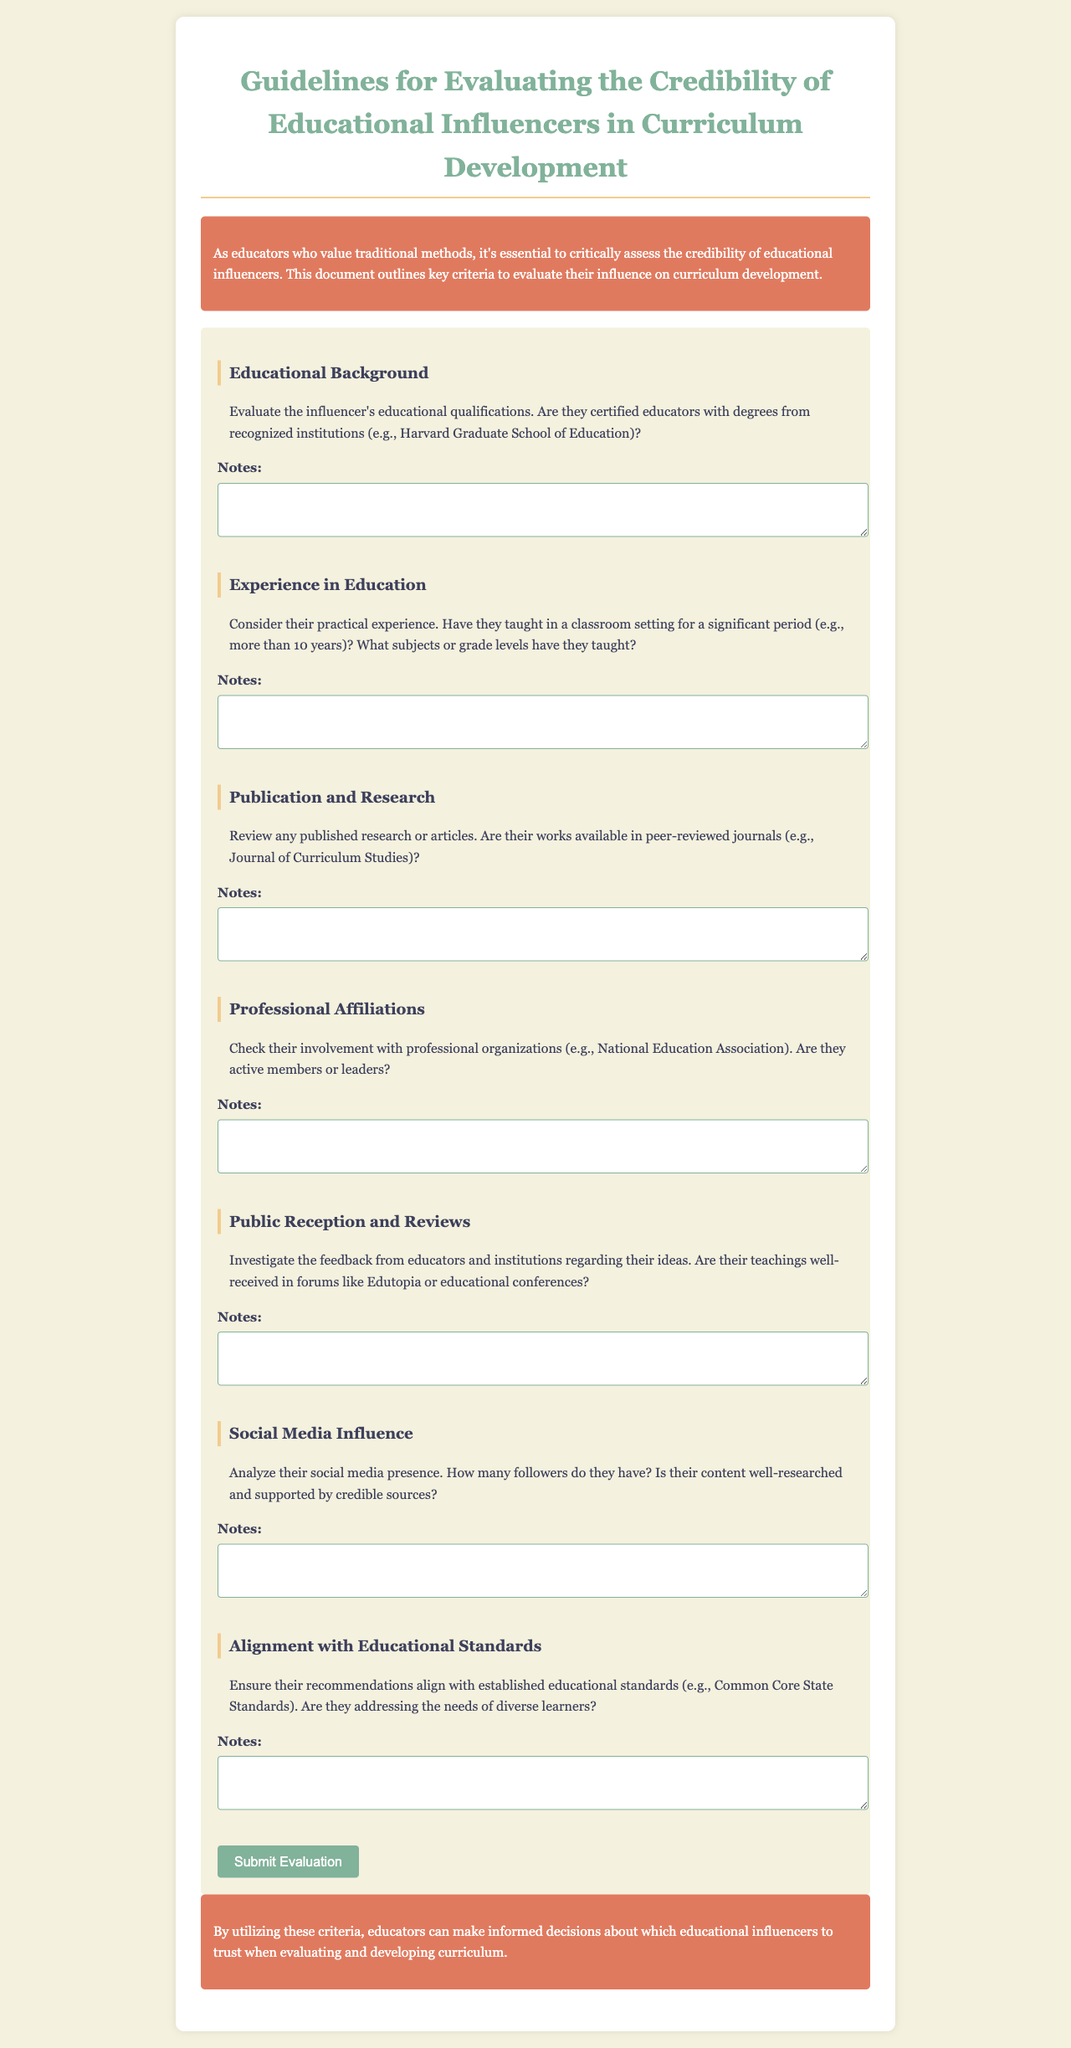What is the title of the document? The title of the document is clearly stated in the header, which is "Guidelines for Evaluating the Credibility of Educational Influencers in Curriculum Development."
Answer: Guidelines for Evaluating the Credibility of Educational Influencers in Curriculum Development How many criteria are listed for evaluating educational influencers? The number of criteria can be counted in the document, which are seven in total.
Answer: Seven What is one suggested requirement for the influencer's educational background? The document specifies that influencers should ideally be certified educators with degrees from recognized institutions such as Harvard Graduate School of Education.
Answer: Certified educators with degrees from recognized institutions What type of journals should their publications be in? The document mentions that the influencer's works should be available in peer-reviewed journals, such as the Journal of Curriculum Studies.
Answer: Peer-reviewed journals What social media factor is suggested to analyze? The document suggests analyzing the influencer's social media presence, particularly the number of followers.
Answer: Number of followers Which professional organization is mentioned in relation to professional affiliations? The document refers to the National Education Association as an example of a professional organization.
Answer: National Education Association What is one of the conclusions drawn about the criteria? The conclusion emphasizes that utilizing these criteria helps educators make informed decisions regarding trusted educational influencers.
Answer: Make informed decisions What color is used for the introduction and conclusion sections? The introduction and conclusion sections are colored in a specific hue, which is indicated as the color code #e07a5f.
Answer: e07a5f 